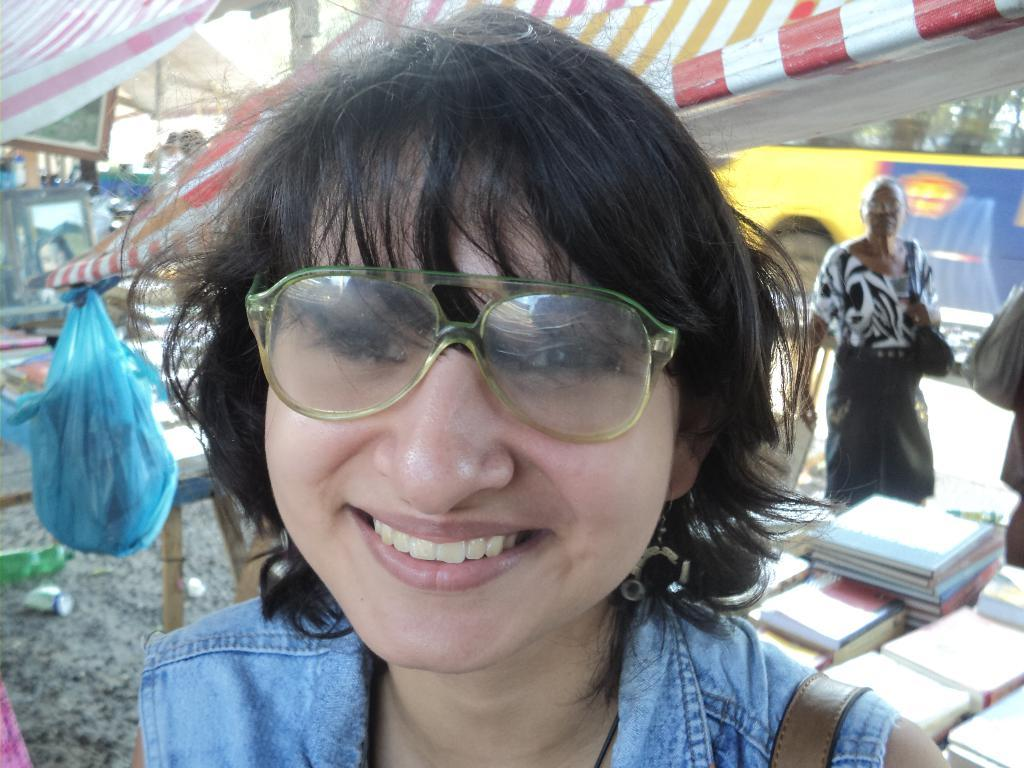Who is present in the image? There is a woman in the image. What is the woman wearing on her face? The woman is wearing goggles. What expression does the woman have? The woman is smiling. What can be seen in the background of the image? There are tents, a plastic cover, books, a bottle, and people in the background of the image. What color is the paint on the lumber in the image? There is no paint or lumber present in the image. 